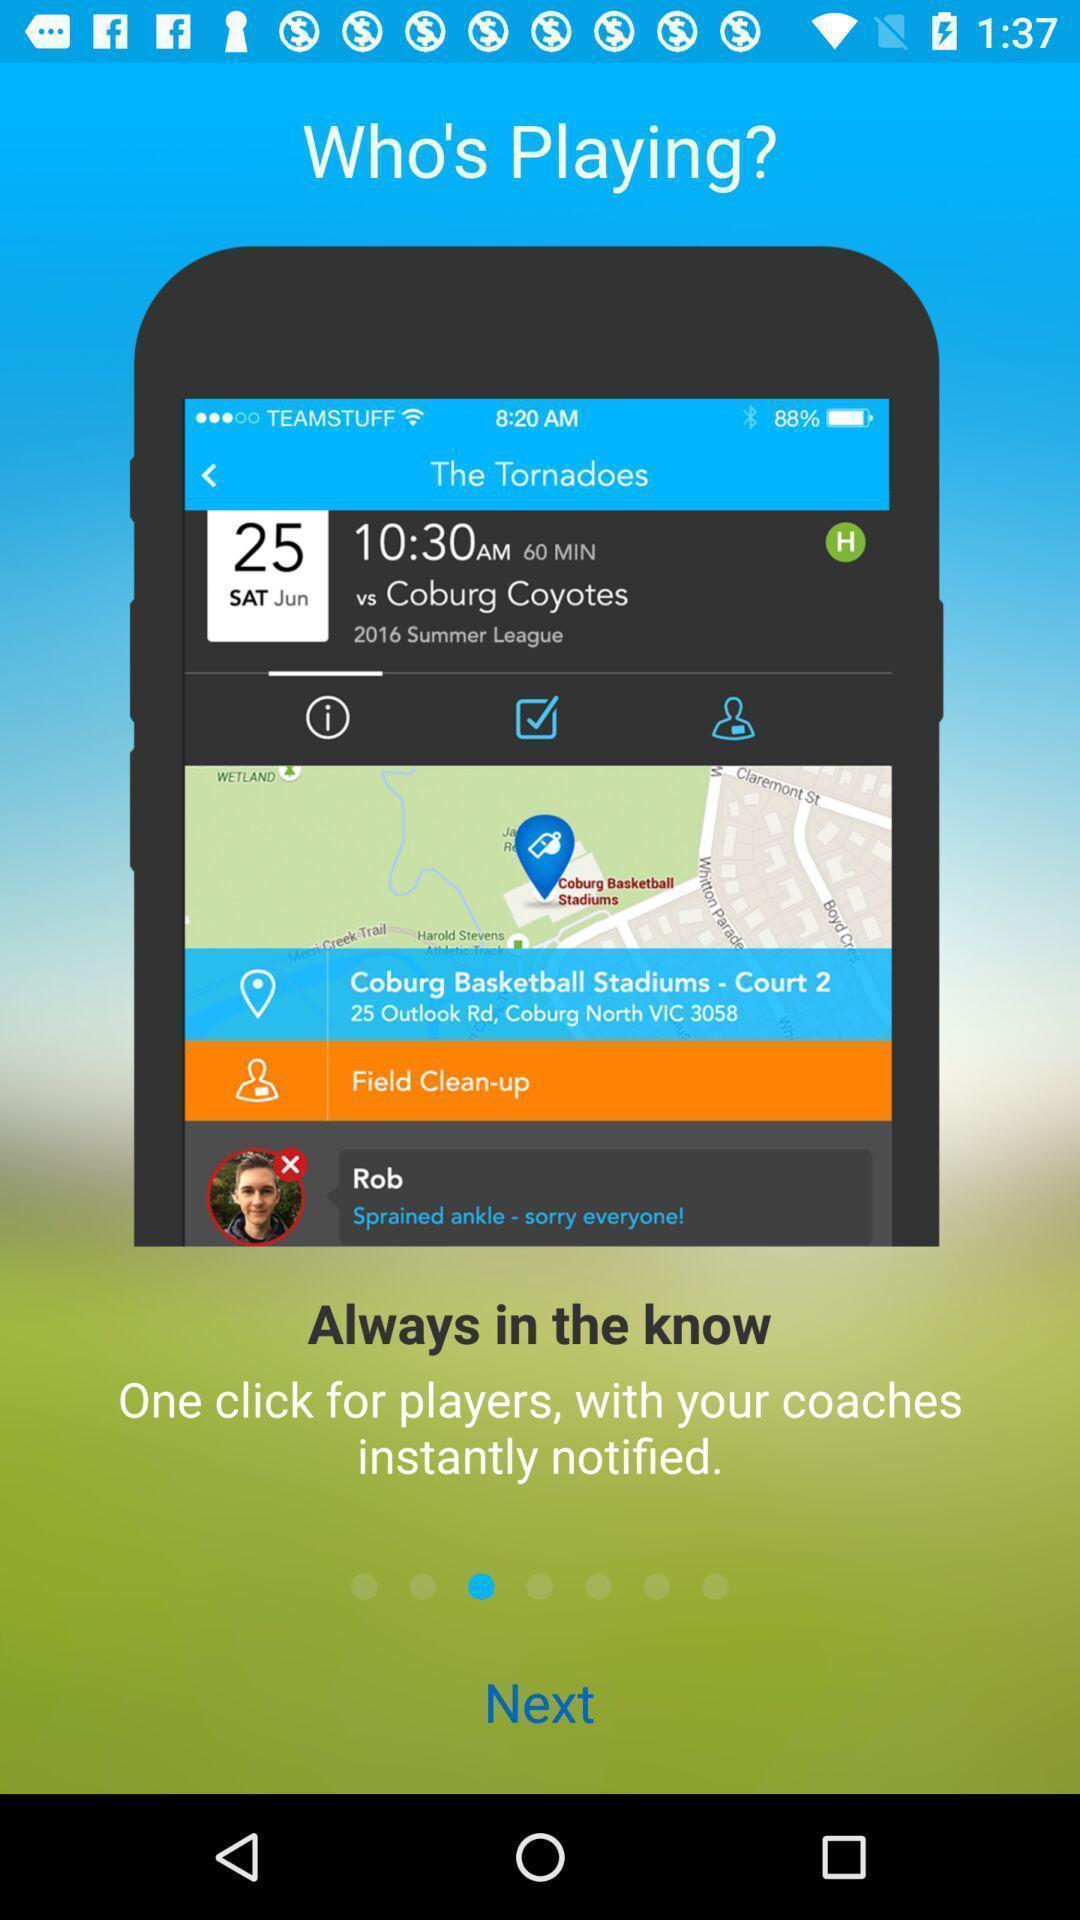Provide a description of this screenshot. Welcome page. 